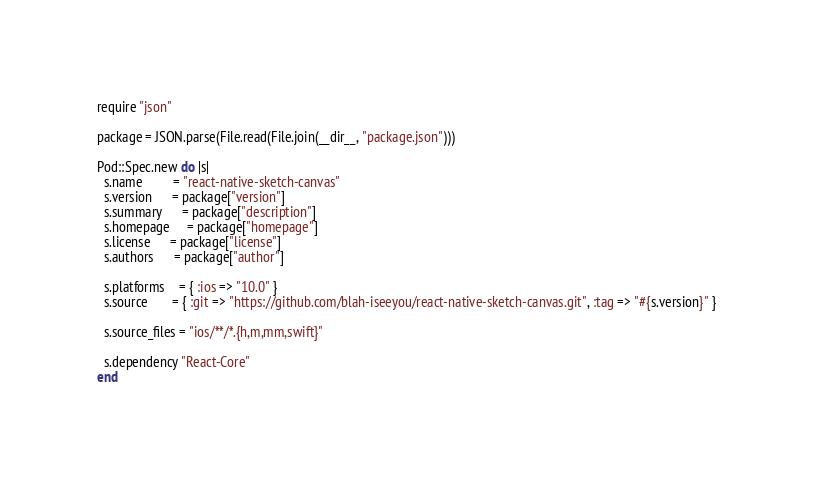Convert code to text. <code><loc_0><loc_0><loc_500><loc_500><_Ruby_>require "json"

package = JSON.parse(File.read(File.join(__dir__, "package.json")))

Pod::Spec.new do |s|
  s.name         = "react-native-sketch-canvas"
  s.version      = package["version"]
  s.summary      = package["description"]
  s.homepage     = package["homepage"]
  s.license      = package["license"]
  s.authors      = package["author"]

  s.platforms    = { :ios => "10.0" }
  s.source       = { :git => "https://github.com/blah-iseeyou/react-native-sketch-canvas.git", :tag => "#{s.version}" }

  s.source_files = "ios/**/*.{h,m,mm,swift}"

  s.dependency "React-Core"
end
</code> 